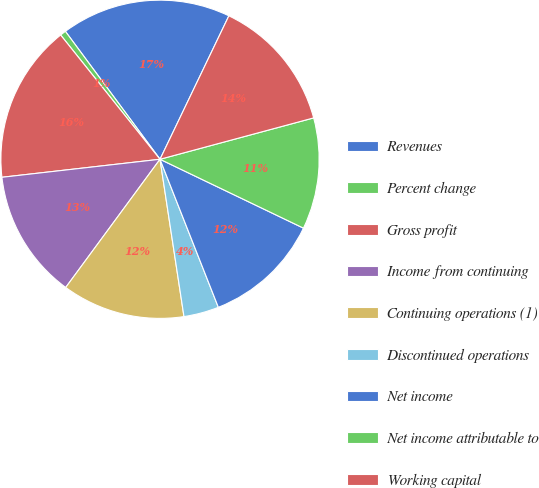Convert chart. <chart><loc_0><loc_0><loc_500><loc_500><pie_chart><fcel>Revenues<fcel>Percent change<fcel>Gross profit<fcel>Income from continuing<fcel>Continuing operations (1)<fcel>Discontinued operations<fcel>Net income<fcel>Net income attributable to<fcel>Working capital<nl><fcel>17.26%<fcel>0.6%<fcel>16.07%<fcel>13.1%<fcel>12.5%<fcel>3.57%<fcel>11.9%<fcel>11.31%<fcel>13.69%<nl></chart> 